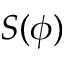Convert formula to latex. <formula><loc_0><loc_0><loc_500><loc_500>S ( \phi )</formula> 